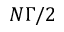<formula> <loc_0><loc_0><loc_500><loc_500>N \Gamma / 2</formula> 